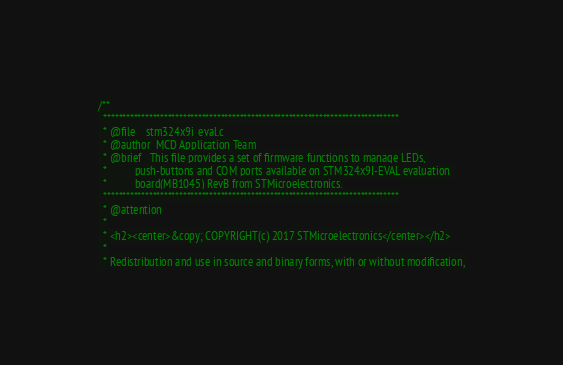Convert code to text. <code><loc_0><loc_0><loc_500><loc_500><_C_>/**
  ******************************************************************************
  * @file    stm324x9i_eval.c
  * @author  MCD Application Team
  * @brief   This file provides a set of firmware functions to manage LEDs, 
  *          push-buttons and COM ports available on STM324x9I-EVAL evaluation 
  *          board(MB1045) RevB from STMicroelectronics.
  ******************************************************************************
  * @attention
  *
  * <h2><center>&copy; COPYRIGHT(c) 2017 STMicroelectronics</center></h2>
  *
  * Redistribution and use in source and binary forms, with or without modification,</code> 